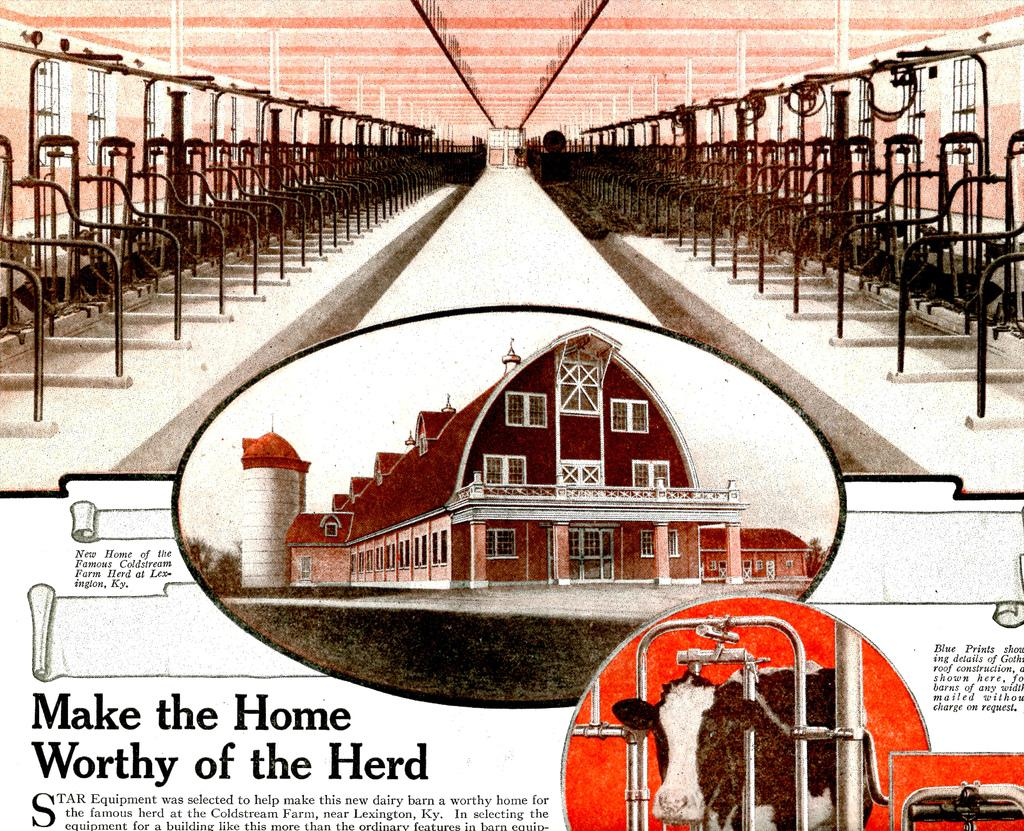<image>
Offer a succinct explanation of the picture presented. An article showcasing a barn with the title make the home worthy of the herd. 